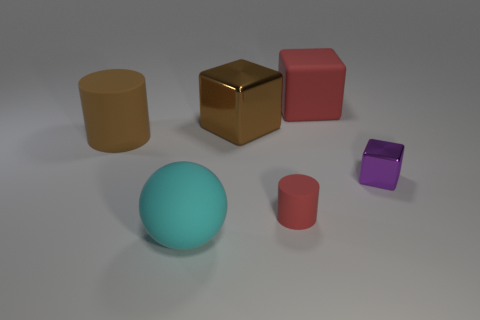There is a matte cylinder in front of the large brown cylinder; is its color the same as the metal thing behind the brown rubber object?
Your answer should be very brief. No. Is there a ball?
Offer a terse response. Yes. Are there any tiny blue things that have the same material as the small purple cube?
Make the answer very short. No. Is there anything else that is made of the same material as the ball?
Your answer should be very brief. Yes. What is the color of the large cylinder?
Keep it short and to the point. Brown. What shape is the rubber object that is the same color as the large metal thing?
Your answer should be compact. Cylinder. There is a rubber cylinder that is the same size as the matte block; what is its color?
Offer a very short reply. Brown. What number of matte objects are brown objects or small cylinders?
Offer a very short reply. 2. What number of objects are both in front of the small purple shiny object and left of the big metallic object?
Make the answer very short. 1. Is there anything else that has the same shape as the cyan object?
Provide a short and direct response. No. 